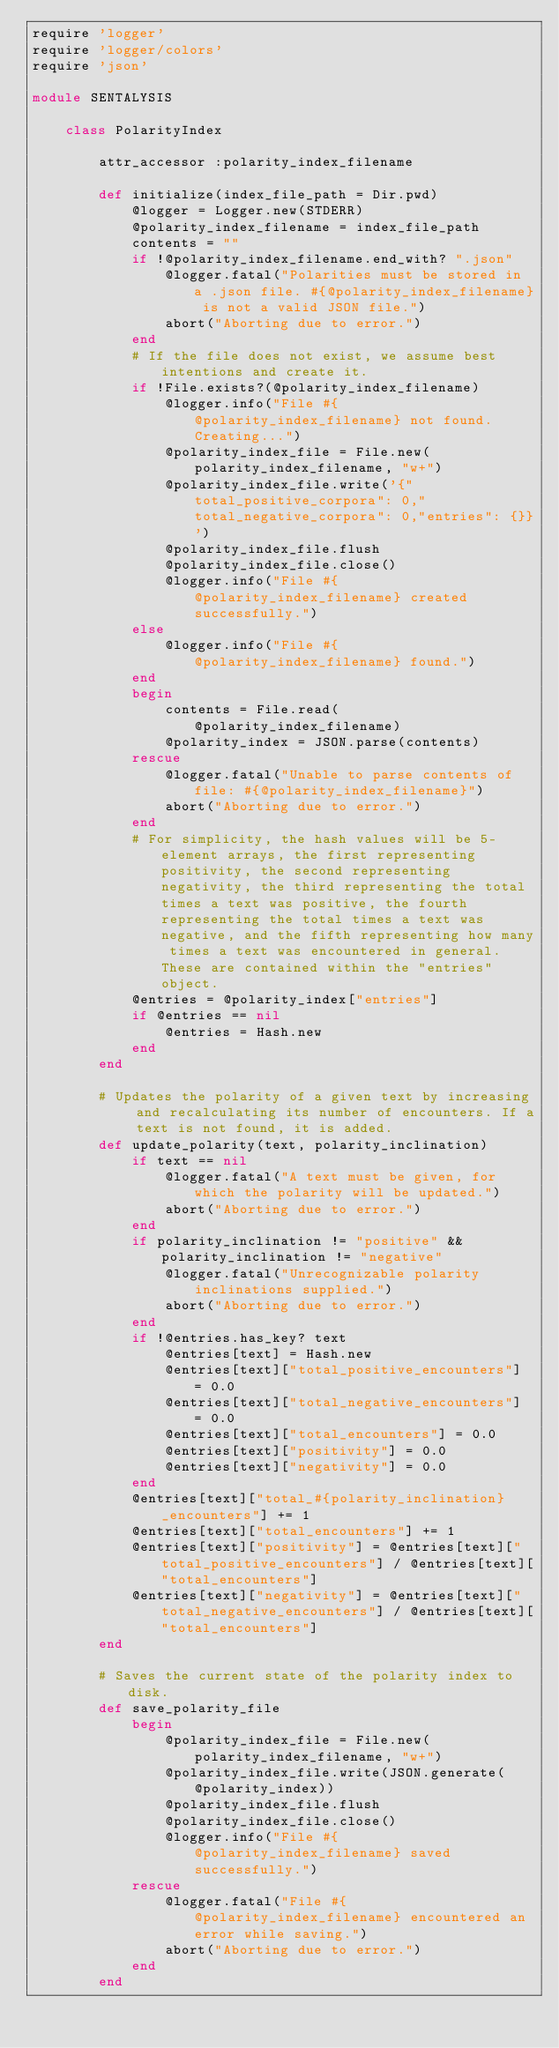<code> <loc_0><loc_0><loc_500><loc_500><_Ruby_>require 'logger'
require 'logger/colors'
require 'json'

module SENTALYSIS

    class PolarityIndex
        
        attr_accessor :polarity_index_filename
        
        def initialize(index_file_path = Dir.pwd)
            @logger = Logger.new(STDERR)
            @polarity_index_filename = index_file_path
            contents = ""
            if !@polarity_index_filename.end_with? ".json"
                @logger.fatal("Polarities must be stored in a .json file. #{@polarity_index_filename} is not a valid JSON file.")
                abort("Aborting due to error.")
            end
            # If the file does not exist, we assume best intentions and create it.
            if !File.exists?(@polarity_index_filename)
                @logger.info("File #{@polarity_index_filename} not found. Creating...")
                @polarity_index_file = File.new(polarity_index_filename, "w+")
                @polarity_index_file.write('{"total_positive_corpora": 0,"total_negative_corpora": 0,"entries": {}}')
                @polarity_index_file.flush
                @polarity_index_file.close()
                @logger.info("File #{@polarity_index_filename} created successfully.")
            else
                @logger.info("File #{@polarity_index_filename} found.")
            end
            begin
                contents = File.read(@polarity_index_filename)
                @polarity_index = JSON.parse(contents)
            rescue
                @logger.fatal("Unable to parse contents of file: #{@polarity_index_filename}")
                abort("Aborting due to error.")
            end
            # For simplicity, the hash values will be 5-element arrays, the first representing positivity, the second representing negativity, the third representing the total times a text was positive, the fourth representing the total times a text was negative, and the fifth representing how many times a text was encountered in general. These are contained within the "entries" object.
            @entries = @polarity_index["entries"]
            if @entries == nil
                @entries = Hash.new
            end
        end
        
        # Updates the polarity of a given text by increasing and recalculating its number of encounters. If a text is not found, it is added.
        def update_polarity(text, polarity_inclination)
            if text == nil
                @logger.fatal("A text must be given, for which the polarity will be updated.")
                abort("Aborting due to error.")
            end
            if polarity_inclination != "positive" && polarity_inclination != "negative"
                @logger.fatal("Unrecognizable polarity inclinations supplied.")
                abort("Aborting due to error.")
            end
            if !@entries.has_key? text
                @entries[text] = Hash.new
                @entries[text]["total_positive_encounters"] = 0.0
                @entries[text]["total_negative_encounters"] = 0.0
                @entries[text]["total_encounters"] = 0.0
                @entries[text]["positivity"] = 0.0
                @entries[text]["negativity"] = 0.0
            end
            @entries[text]["total_#{polarity_inclination}_encounters"] += 1
            @entries[text]["total_encounters"] += 1
            @entries[text]["positivity"] = @entries[text]["total_positive_encounters"] / @entries[text]["total_encounters"] 
            @entries[text]["negativity"] = @entries[text]["total_negative_encounters"] / @entries[text]["total_encounters"]
        end
        
        # Saves the current state of the polarity index to disk.
        def save_polarity_file
            begin
                @polarity_index_file = File.new(polarity_index_filename, "w+")
                @polarity_index_file.write(JSON.generate(@polarity_index))
                @polarity_index_file.flush
                @polarity_index_file.close()
                @logger.info("File #{@polarity_index_filename} saved successfully.")
            rescue
                @logger.fatal("File #{@polarity_index_filename} encountered an error while saving.")
                abort("Aborting due to error.")
            end
        end
        </code> 